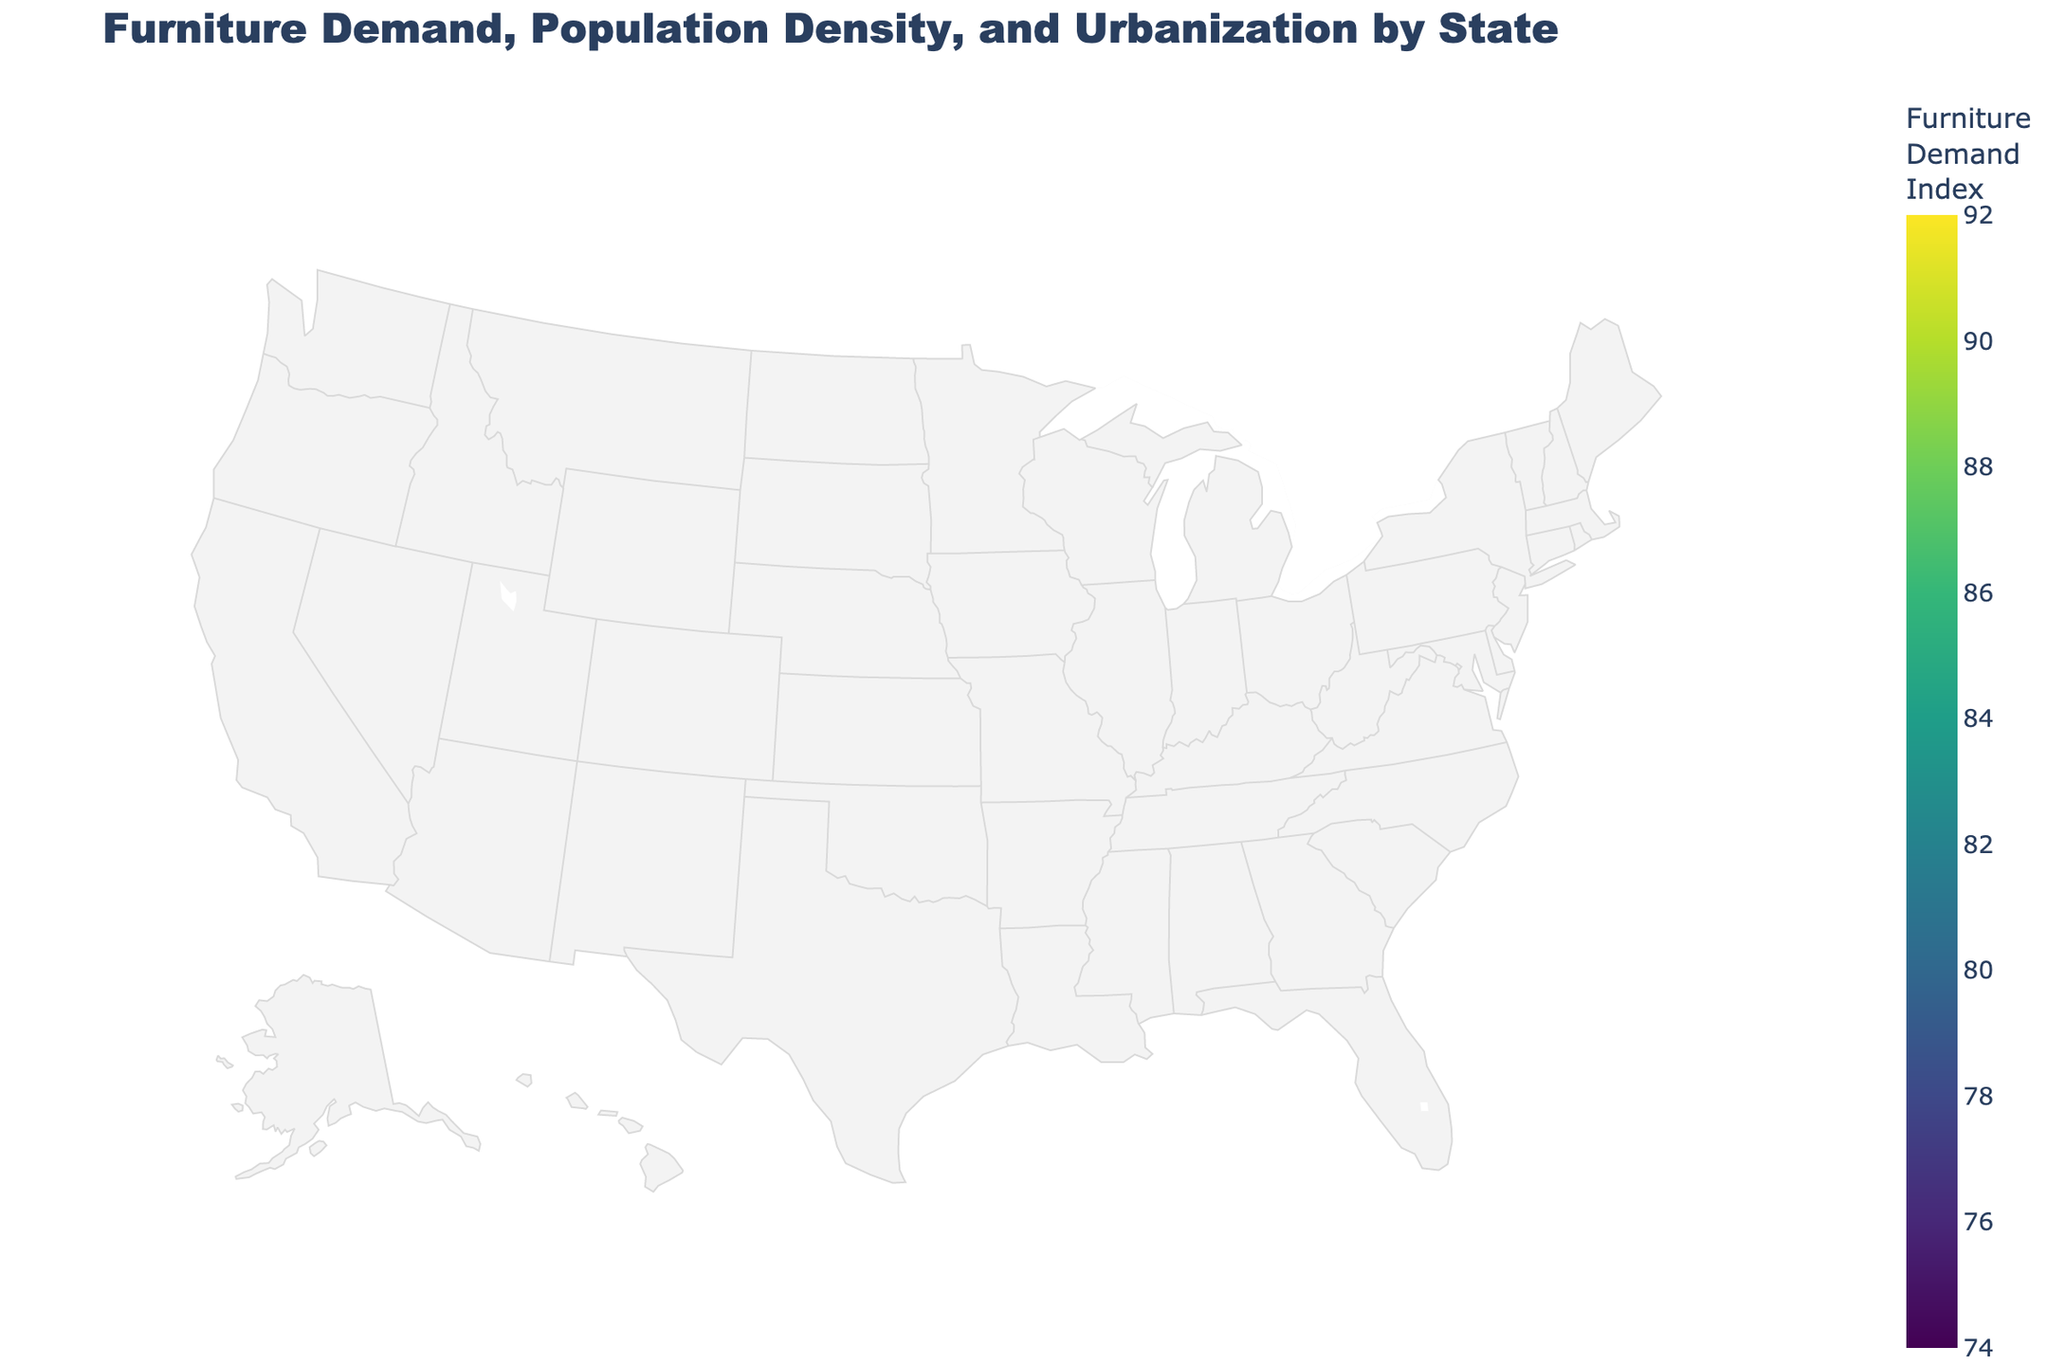What state has the highest furniture demand index? The state with the highest furniture demand index can be found by looking for the brightest color in the color scale used in the plot.
Answer: New Jersey How does the furniture demand index of Florida compare to that of Ohio? To answer this, look at the color and value of the furniture demand index for both states. Florida has a furniture demand index of 90, while Ohio has 76. Florida's index is higher.
Answer: Florida's index is higher than Ohio's Which state has the highest population density? Check the bubble size representing each state. The largest bubble indicates the highest population density.
Answer: New Jersey What is the urbanization level of California, and how does it compare to Texas? Look at the text annotations for urbanization levels over California and Texas. California has 95%, and Texas has 84.7%. California's urbanization level is higher.
Answer: California: 95%, higher than Texas Compare the furniture demand index of the states with the lowest population density and the highest population density. Oregon has the lowest population density, and New Jersey has the highest. Compare their furniture demand indices: Oregon has 82, and New Jersey has 89.
Answer: Oregon: 82, New Jersey: 89 Which states have an urbanization level above 90%? States with urbanization levels above 90% will have text annotations indicating urbanization levels of greater than 90%. These states are California, Florida, and Massachusetts.
Answer: California, Florida, Massachusetts What is the relationship between population density and furniture demand index in New York and Colorado? Look at the population density and furniture demand index for both New York (412.8, 88) and Colorado (52.6, 83). New York has higher values for both metrics compared to Colorado.
Answer: New York has higher values in both metrics Find the median furniture demand index across all states. List the furniture demand indices: [92, 88, 85, 90, 82, 79, 76, 81, 78, 75, 86, 84, 87, 80, 83, 89, 85, 74, 77]. The median value of an ordered list of 19 items (middle item) is 82.
Answer: 82 Does a higher urbanization level always mean a higher furniture demand index? Compare urbanization levels and furniture demand indices among the states. For example, California (95, 92) vs. New York (87.9, 88), there are both consistent and inconsistent patterns.
Answer: Not always Which state has the lowest urbanization level, and what is its furniture demand index? Find the urbanization level and corresponding furniture demand index. Minnesota has the lowest urbanization level (66.1%), and its index is 77.
Answer: Minnesota, Furniture Demand Index: 77 